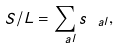<formula> <loc_0><loc_0><loc_500><loc_500>S / L = \sum _ { \ a l } s _ { \ a l } ,</formula> 